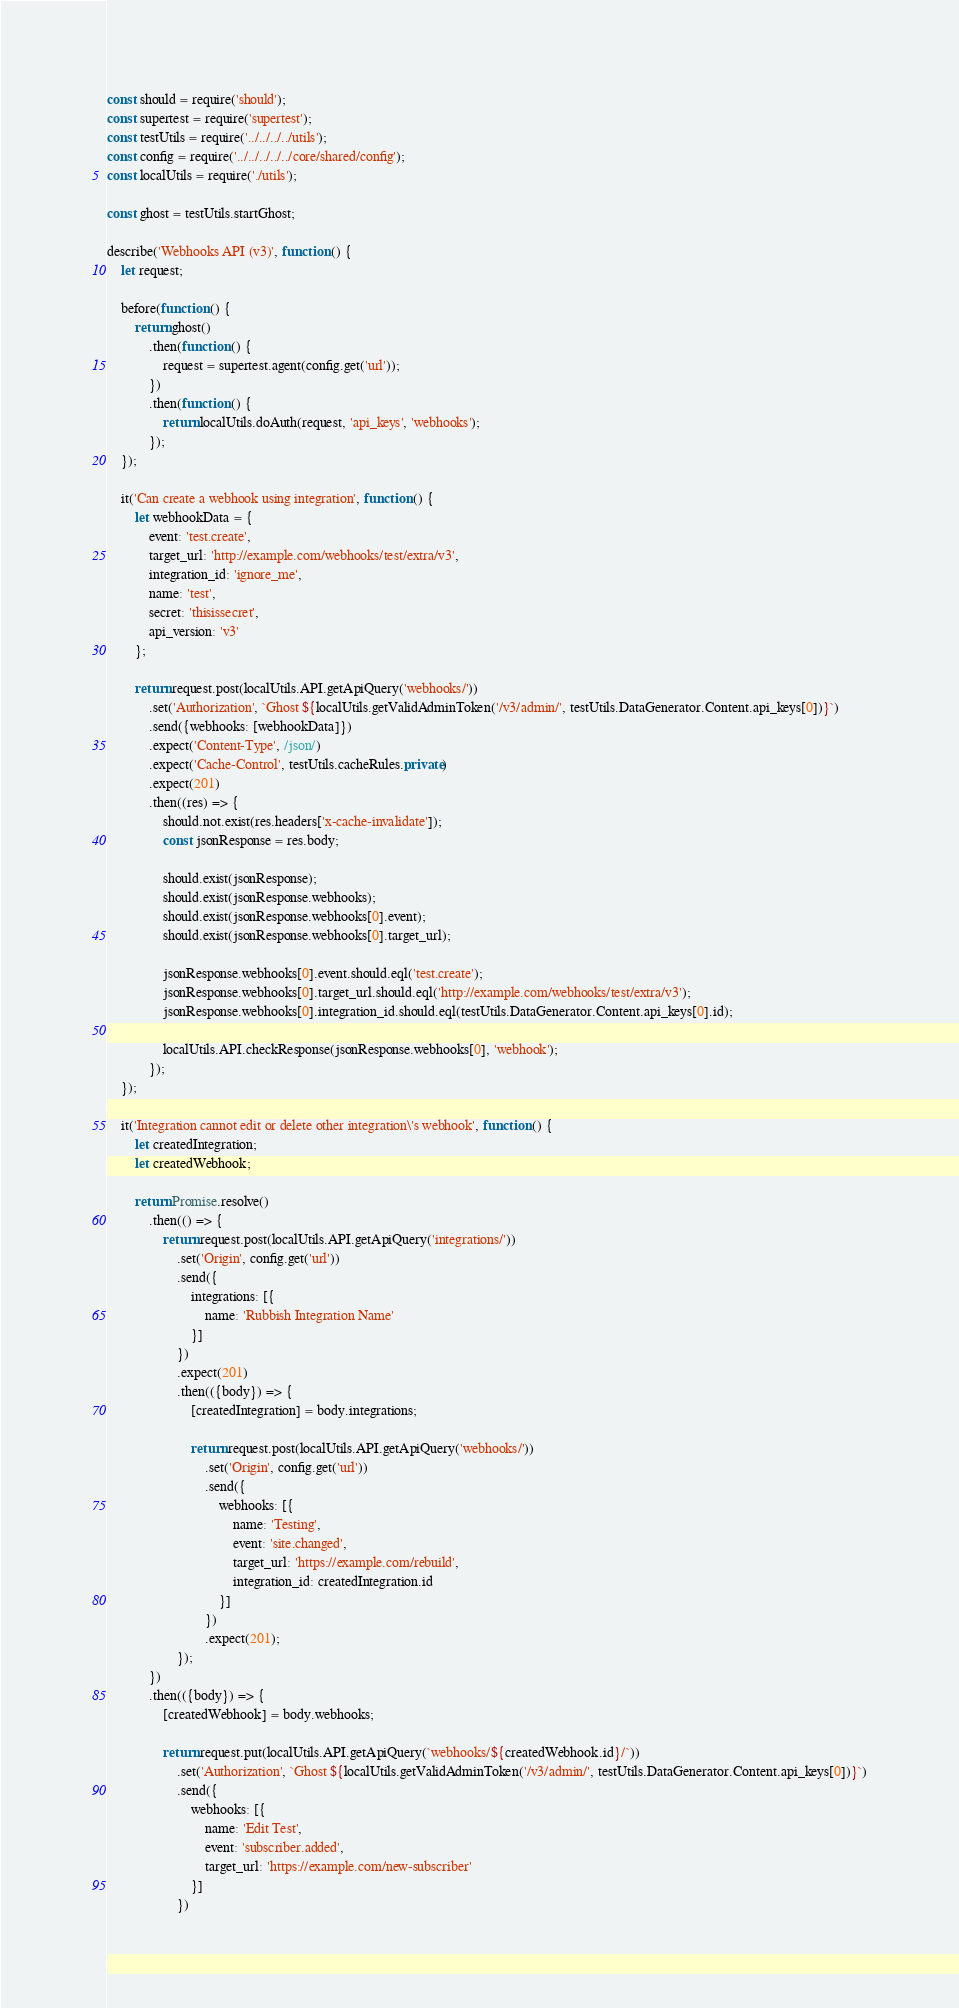Convert code to text. <code><loc_0><loc_0><loc_500><loc_500><_JavaScript_>const should = require('should');
const supertest = require('supertest');
const testUtils = require('../../../../utils');
const config = require('../../../../../core/shared/config');
const localUtils = require('./utils');

const ghost = testUtils.startGhost;

describe('Webhooks API (v3)', function () {
    let request;

    before(function () {
        return ghost()
            .then(function () {
                request = supertest.agent(config.get('url'));
            })
            .then(function () {
                return localUtils.doAuth(request, 'api_keys', 'webhooks');
            });
    });

    it('Can create a webhook using integration', function () {
        let webhookData = {
            event: 'test.create',
            target_url: 'http://example.com/webhooks/test/extra/v3',
            integration_id: 'ignore_me',
            name: 'test',
            secret: 'thisissecret',
            api_version: 'v3'
        };

        return request.post(localUtils.API.getApiQuery('webhooks/'))
            .set('Authorization', `Ghost ${localUtils.getValidAdminToken('/v3/admin/', testUtils.DataGenerator.Content.api_keys[0])}`)
            .send({webhooks: [webhookData]})
            .expect('Content-Type', /json/)
            .expect('Cache-Control', testUtils.cacheRules.private)
            .expect(201)
            .then((res) => {
                should.not.exist(res.headers['x-cache-invalidate']);
                const jsonResponse = res.body;

                should.exist(jsonResponse);
                should.exist(jsonResponse.webhooks);
                should.exist(jsonResponse.webhooks[0].event);
                should.exist(jsonResponse.webhooks[0].target_url);

                jsonResponse.webhooks[0].event.should.eql('test.create');
                jsonResponse.webhooks[0].target_url.should.eql('http://example.com/webhooks/test/extra/v3');
                jsonResponse.webhooks[0].integration_id.should.eql(testUtils.DataGenerator.Content.api_keys[0].id);

                localUtils.API.checkResponse(jsonResponse.webhooks[0], 'webhook');
            });
    });

    it('Integration cannot edit or delete other integration\'s webhook', function () {
        let createdIntegration;
        let createdWebhook;

        return Promise.resolve()
            .then(() => {
                return request.post(localUtils.API.getApiQuery('integrations/'))
                    .set('Origin', config.get('url'))
                    .send({
                        integrations: [{
                            name: 'Rubbish Integration Name'
                        }]
                    })
                    .expect(201)
                    .then(({body}) => {
                        [createdIntegration] = body.integrations;

                        return request.post(localUtils.API.getApiQuery('webhooks/'))
                            .set('Origin', config.get('url'))
                            .send({
                                webhooks: [{
                                    name: 'Testing',
                                    event: 'site.changed',
                                    target_url: 'https://example.com/rebuild',
                                    integration_id: createdIntegration.id
                                }]
                            })
                            .expect(201);
                    });
            })
            .then(({body}) => {
                [createdWebhook] = body.webhooks;

                return request.put(localUtils.API.getApiQuery(`webhooks/${createdWebhook.id}/`))
                    .set('Authorization', `Ghost ${localUtils.getValidAdminToken('/v3/admin/', testUtils.DataGenerator.Content.api_keys[0])}`)
                    .send({
                        webhooks: [{
                            name: 'Edit Test',
                            event: 'subscriber.added',
                            target_url: 'https://example.com/new-subscriber'
                        }]
                    })</code> 